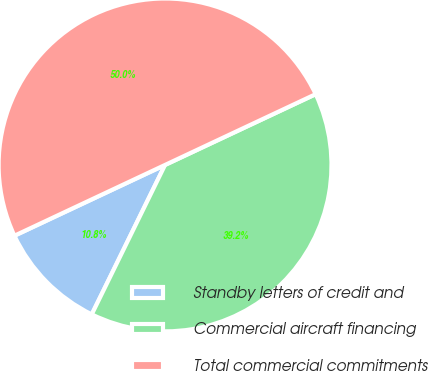Convert chart to OTSL. <chart><loc_0><loc_0><loc_500><loc_500><pie_chart><fcel>Standby letters of credit and<fcel>Commercial aircraft financing<fcel>Total commercial commitments<nl><fcel>10.75%<fcel>39.25%<fcel>50.0%<nl></chart> 